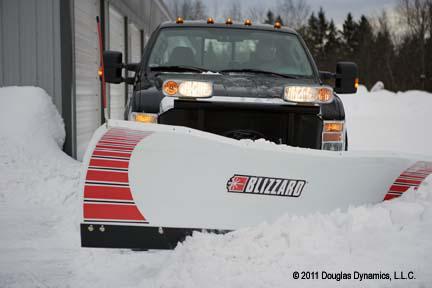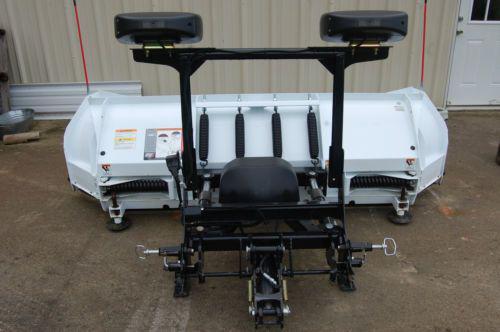The first image is the image on the left, the second image is the image on the right. Assess this claim about the two images: "Snow is being cleared by a vehicle.". Correct or not? Answer yes or no. Yes. The first image is the image on the left, the second image is the image on the right. Examine the images to the left and right. Is the description "One image shows a vehicle pushing a plow through snow." accurate? Answer yes or no. Yes. 